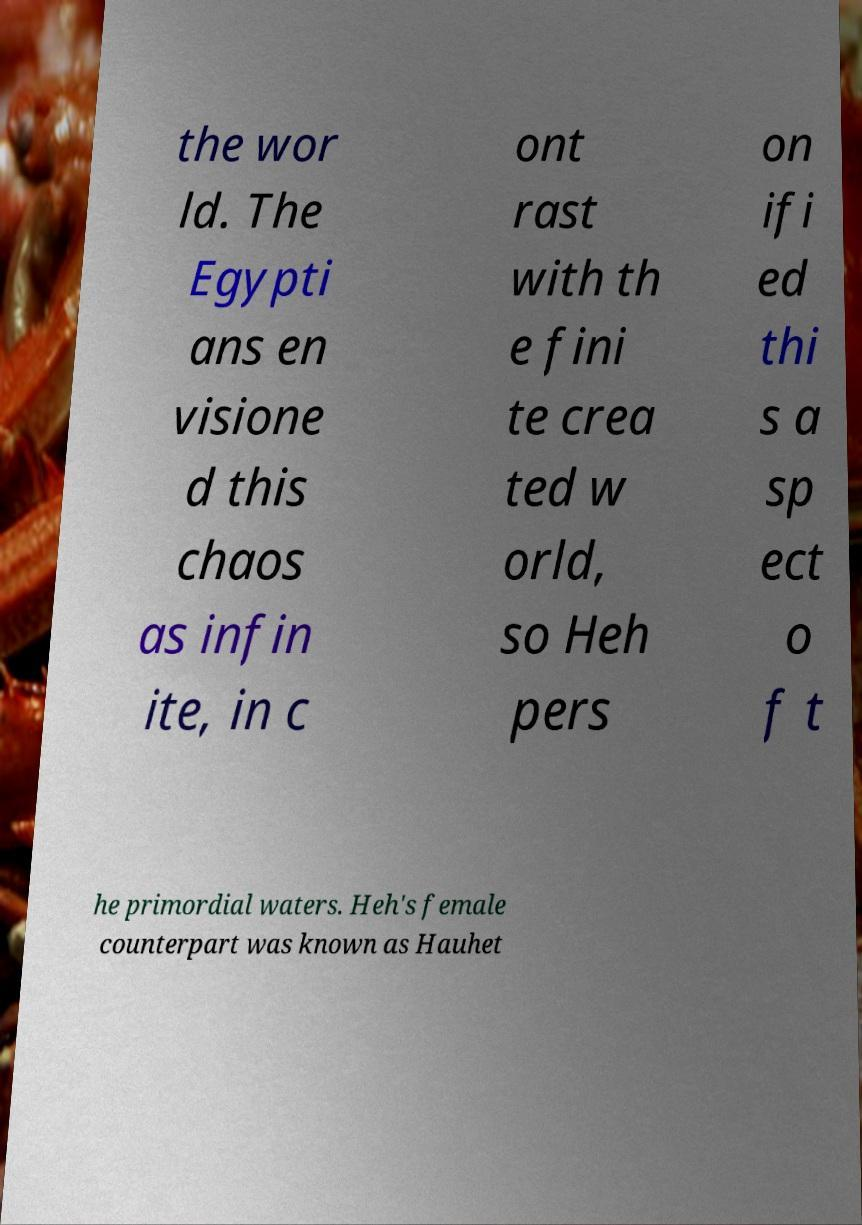Can you accurately transcribe the text from the provided image for me? the wor ld. The Egypti ans en visione d this chaos as infin ite, in c ont rast with th e fini te crea ted w orld, so Heh pers on ifi ed thi s a sp ect o f t he primordial waters. Heh's female counterpart was known as Hauhet 